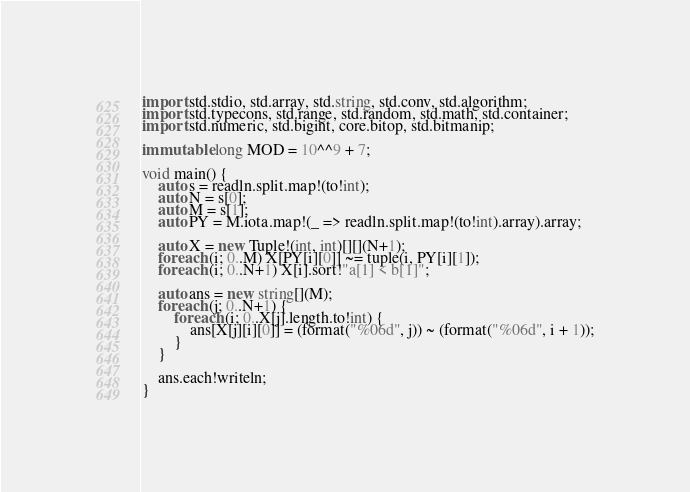Convert code to text. <code><loc_0><loc_0><loc_500><loc_500><_D_>import std.stdio, std.array, std.string, std.conv, std.algorithm;
import std.typecons, std.range, std.random, std.math, std.container;
import std.numeric, std.bigint, core.bitop, std.bitmanip;

immutable long MOD = 10^^9 + 7;

void main() {
    auto s = readln.split.map!(to!int);
    auto N = s[0];
    auto M = s[1];
    auto PY = M.iota.map!(_ => readln.split.map!(to!int).array).array;

    auto X = new Tuple!(int, int)[][](N+1);
    foreach (i; 0..M) X[PY[i][0]] ~= tuple(i, PY[i][1]);
    foreach (i; 0..N+1) X[i].sort!"a[1] < b[1]";

    auto ans = new string[](M);
    foreach (j; 0..N+1) {
        foreach (i; 0..X[j].length.to!int) {
            ans[X[j][i][0]] = (format("%06d", j)) ~ (format("%06d", i + 1));
        }
    }

    ans.each!writeln;
}
</code> 